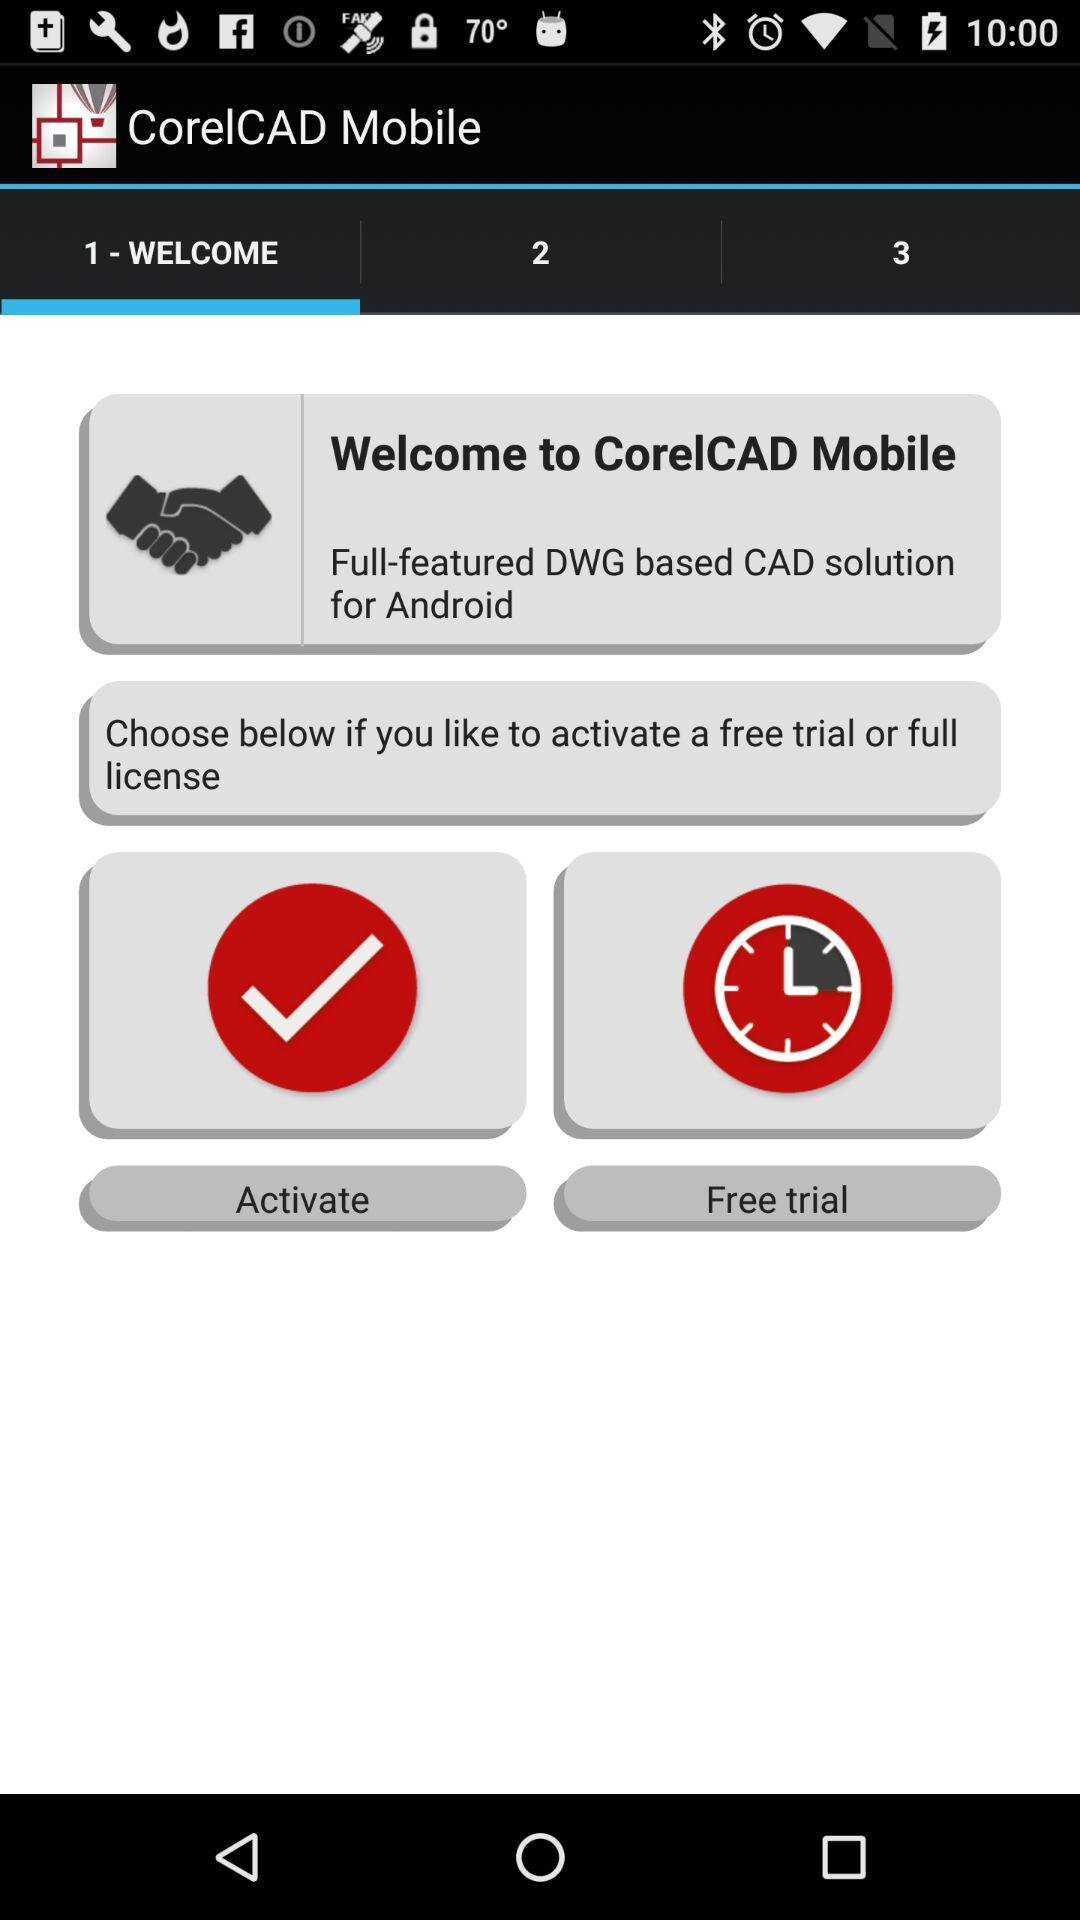What solution software used by CorelCAD Mobile?
When the provided information is insufficient, respond with <no answer>. <no answer> 